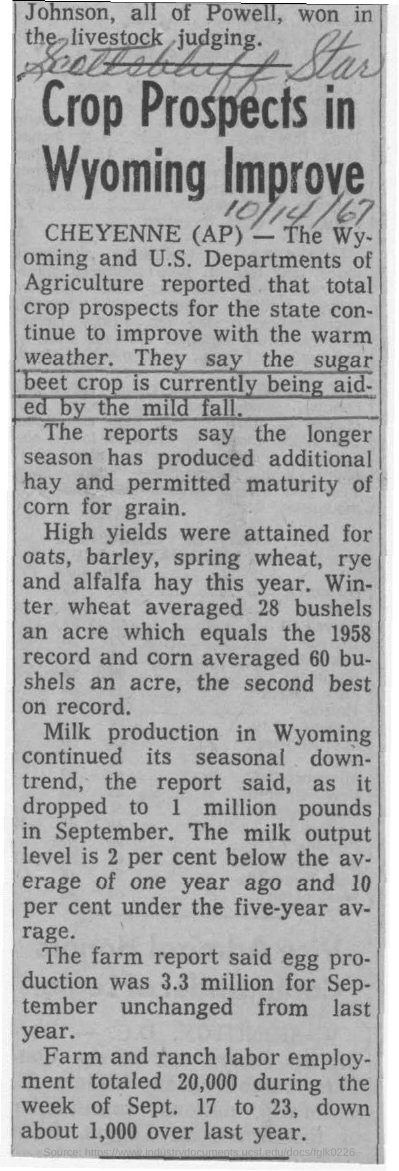What is the headline of this news?
Provide a succinct answer. Crop Prospects in Wyoming Improve. Which crops attained high yields this year as per the news?
Offer a terse response. Oats, barley, spring wheat, rye and alfalfa hay. In which month, milk production in Wyoming dropped to 1 million pounds?
Provide a succinct answer. September. How much was the egg production for september as per the farm report?
Make the answer very short. 3.3 million. 